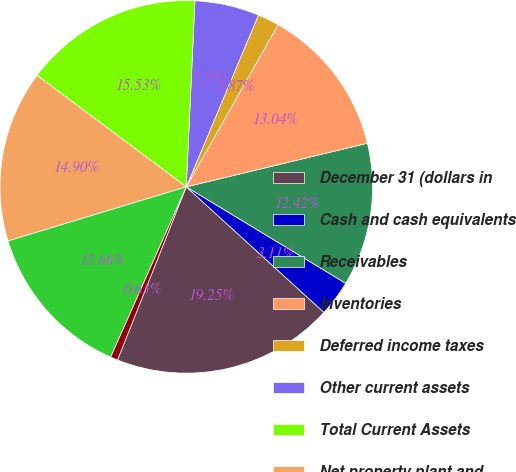<chart> <loc_0><loc_0><loc_500><loc_500><pie_chart><fcel>December 31 (dollars in<fcel>Cash and cash equivalents<fcel>Receivables<fcel>Inventories<fcel>Deferred income taxes<fcel>Other current assets<fcel>Total Current Assets<fcel>Net property plant and<fcel>Goodwill<fcel>Other intangibles<nl><fcel>19.25%<fcel>3.11%<fcel>12.42%<fcel>13.04%<fcel>1.87%<fcel>5.59%<fcel>15.53%<fcel>14.9%<fcel>13.66%<fcel>0.63%<nl></chart> 